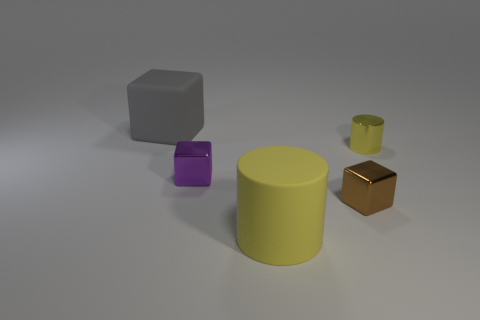Subtract all metal cubes. How many cubes are left? 1 Subtract 1 cylinders. How many cylinders are left? 1 Subtract all blue spheres. How many purple cubes are left? 1 Add 2 large purple matte things. How many objects exist? 7 Subtract all blocks. How many objects are left? 2 Subtract all brown blocks. Subtract all gray cylinders. How many blocks are left? 2 Subtract all blue shiny cylinders. Subtract all large gray things. How many objects are left? 4 Add 2 tiny metallic cylinders. How many tiny metallic cylinders are left? 3 Add 4 tiny cubes. How many tiny cubes exist? 6 Subtract 0 cyan spheres. How many objects are left? 5 